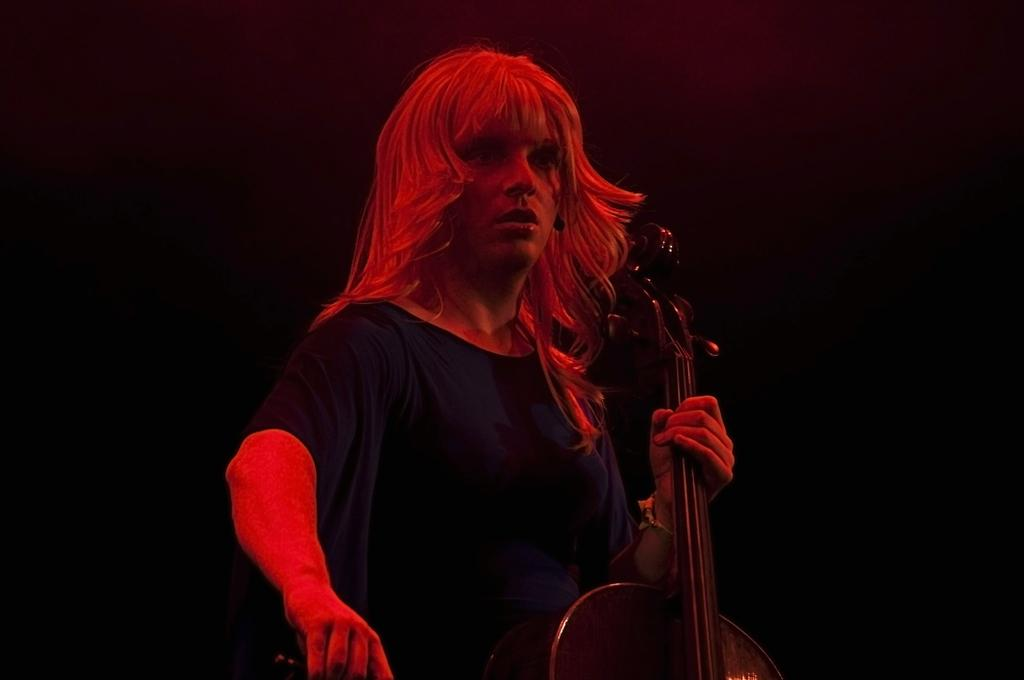Who is the main subject in the image? There is a woman in the image. What is the woman wearing? The woman is wearing a blue t-shirt. What object is the woman holding? The woman is holding a violin. What color is the background of the image? The background of the image is black. Can you hear the bell ringing in the image? There is no bell present in the image, so it cannot be heard. 